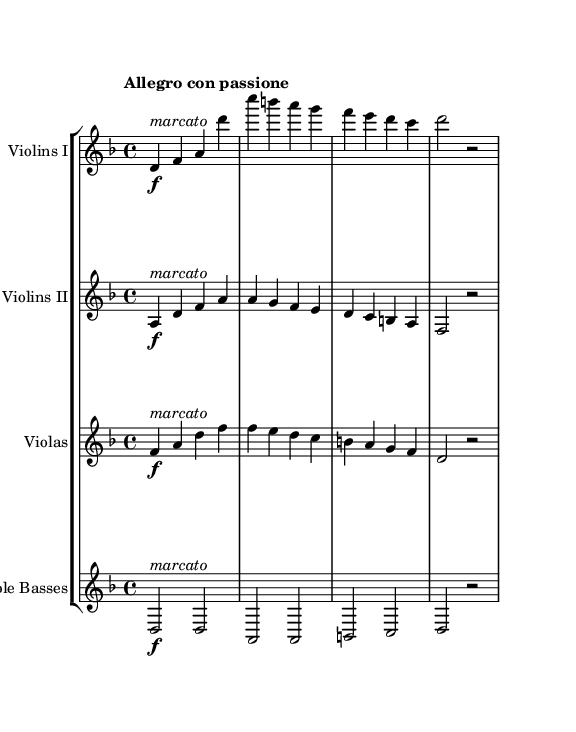What is the key signature of this music? The key signature is indicated at the beginning of the score. It shows a two flat sign, indicating that the piece is in D minor.
Answer: D minor What is the time signature of this music? The time signature is displayed at the beginning of the score as 4/4. This means there are four beats in each measure and the quarter note gets one beat.
Answer: 4/4 What is the tempo marking for this piece? The tempo marking is found at the start of the score, which reads "Allegro con passione," indicating a fast tempo with passion.
Answer: Allegro con passione How many measures are there in this excerpt? To find the number of measures, count the individual groupings of notes and rests. The excerpt contains eight measures in total.
Answer: Eight Which section plays a marcato style primarily? Each string section marked with the term "marcato" plays with an accented style. This term is present for all sections, specifically indicated on each part.
Answer: All sections What type of harmony is primarily reflected in this music? The harmonic structure can be examined through the bass line and chords. The piece exhibits a tonal harmony typical of Romantic-era symphonies, centering around D minor.
Answer: Tonal harmony What is the dynamic marking at the beginning of the strings? The dynamic marking for each string instrument at the beginning of their parts is forte, indicated by the "f." This specifies a loud dynamic throughout the first section.
Answer: Forte 